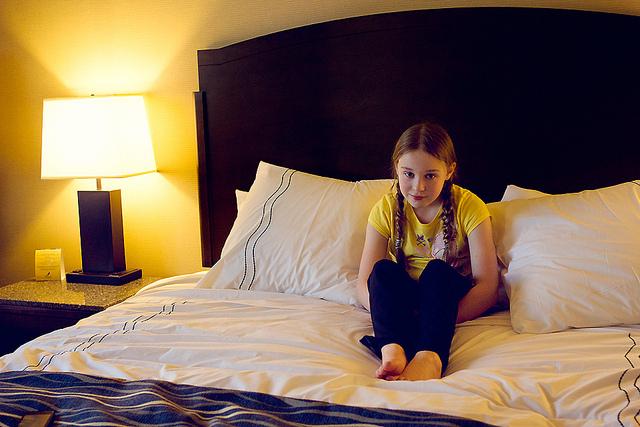What is this person sitting on?
Give a very brief answer. Bed. Is this person sad?
Give a very brief answer. No. What do the wrinkles in the bed indicate?
Keep it brief. Nothing. Is this at a home or hotel?
Keep it brief. Hotel. 